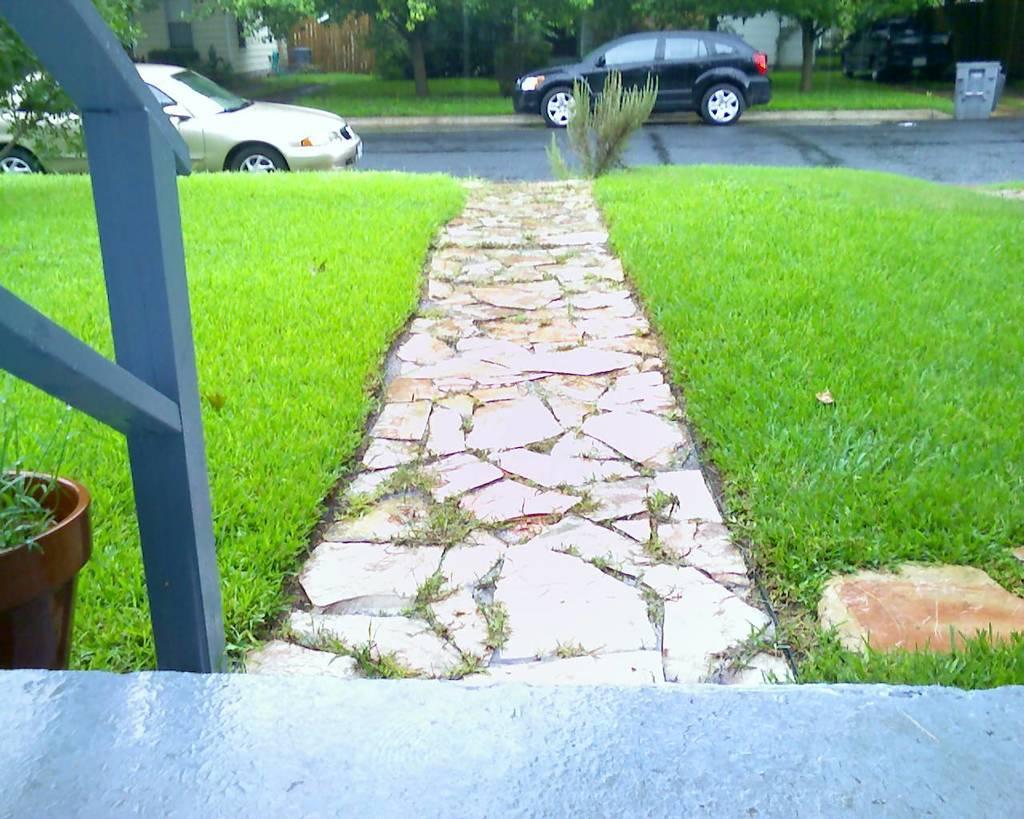How would you summarize this image in a sentence or two? This picture is clicked outside. In the foreground we can see the green grass, metal rods, potted plant. In the background we can see the cars and houses and some other objects and we can see the trees and plants. 